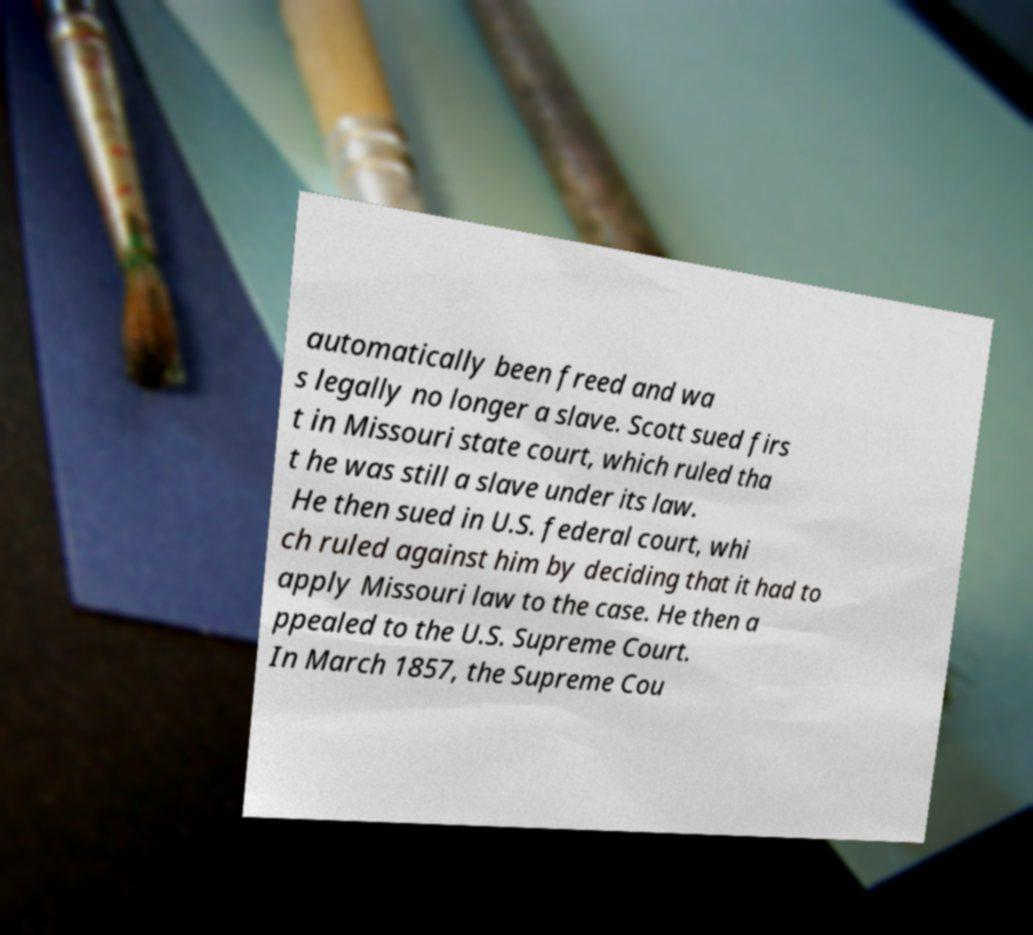Could you assist in decoding the text presented in this image and type it out clearly? automatically been freed and wa s legally no longer a slave. Scott sued firs t in Missouri state court, which ruled tha t he was still a slave under its law. He then sued in U.S. federal court, whi ch ruled against him by deciding that it had to apply Missouri law to the case. He then a ppealed to the U.S. Supreme Court. In March 1857, the Supreme Cou 